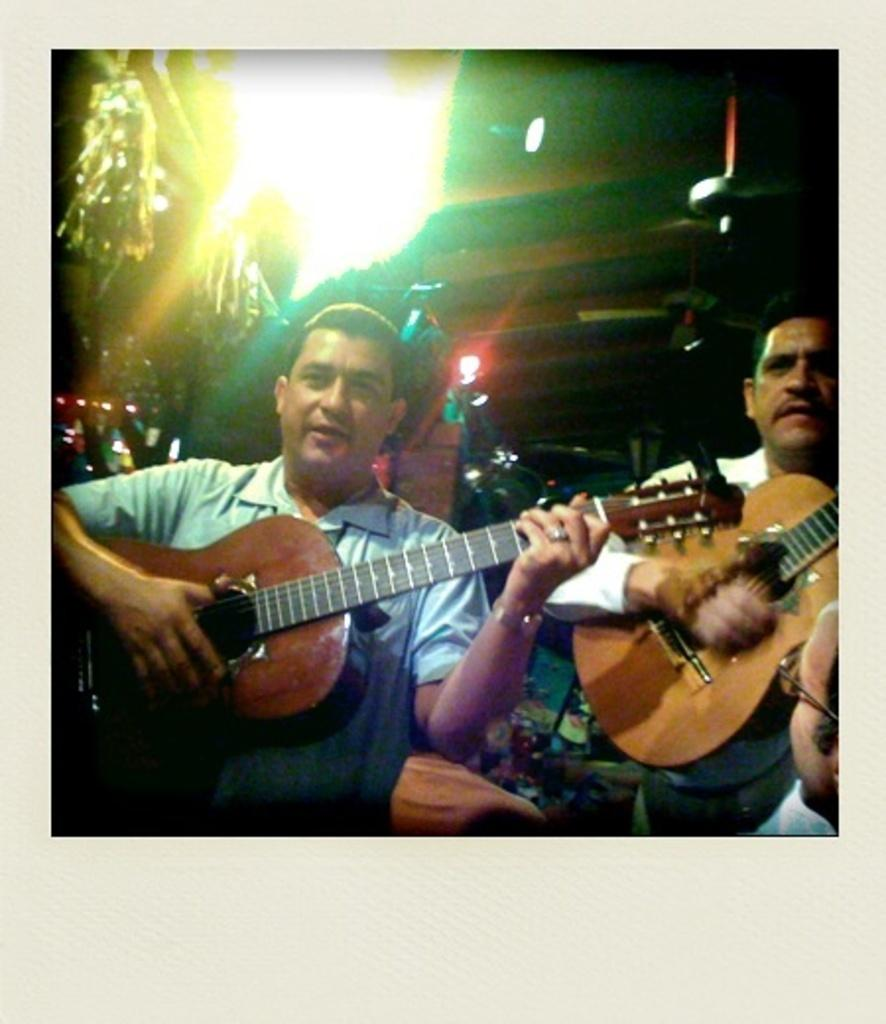How many people are in the image? There are two people in the image. What are the people doing in the image? Both people are playing guitar. What can be seen in the background of the image? There are lights visible in the background of the image. What type of owl can be seen perched on the guitar in the image? There is no owl present in the image; the people are playing guitar without any other visible objects or animals. 